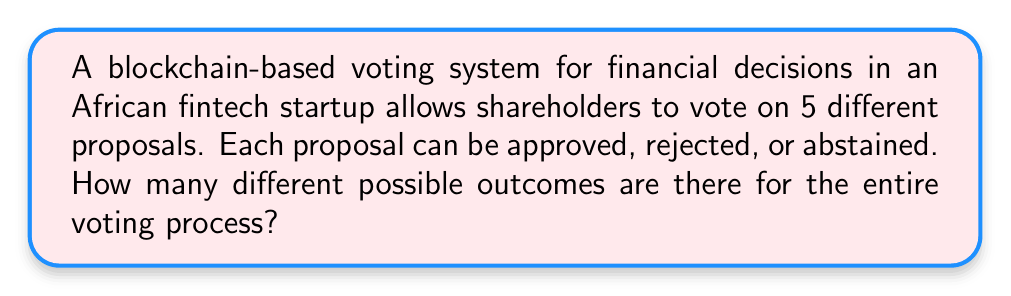Give your solution to this math problem. Let's approach this step-by-step:

1) For each proposal, there are 3 possible outcomes:
   - Approve
   - Reject
   - Abstain

2) This means that for each individual proposal, we have 3 choices.

3) The voting process includes 5 different proposals.

4) To find the total number of possible outcomes, we need to consider all combinations of votes across all 5 proposals.

5) This is a perfect scenario for applying the multiplication principle of counting.

6) The multiplication principle states that if we have $n$ independent events, and each event $i$ has $m_i$ possible outcomes, then the total number of possible outcomes for all events is:

   $$ m_1 \times m_2 \times m_3 \times ... \times m_n $$

7) In our case, we have 5 events (proposals), each with 3 possible outcomes.

8) Therefore, the total number of possible outcomes is:

   $$ 3 \times 3 \times 3 \times 3 \times 3 = 3^5 $$

9) Calculating this:

   $$ 3^5 = 3 \times 3 \times 3 \times 3 \times 3 = 243 $$

Thus, there are 243 different possible outcomes for the entire voting process.
Answer: $3^5 = 243$ 